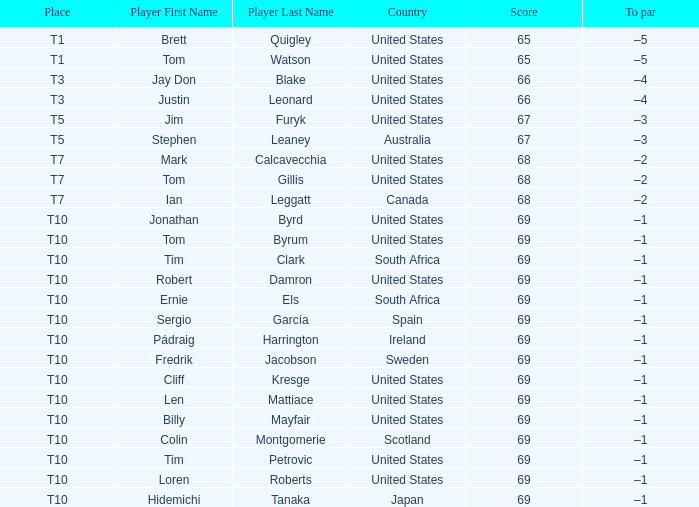What is the average score for the player who is T5 in the United States? 67.0. 